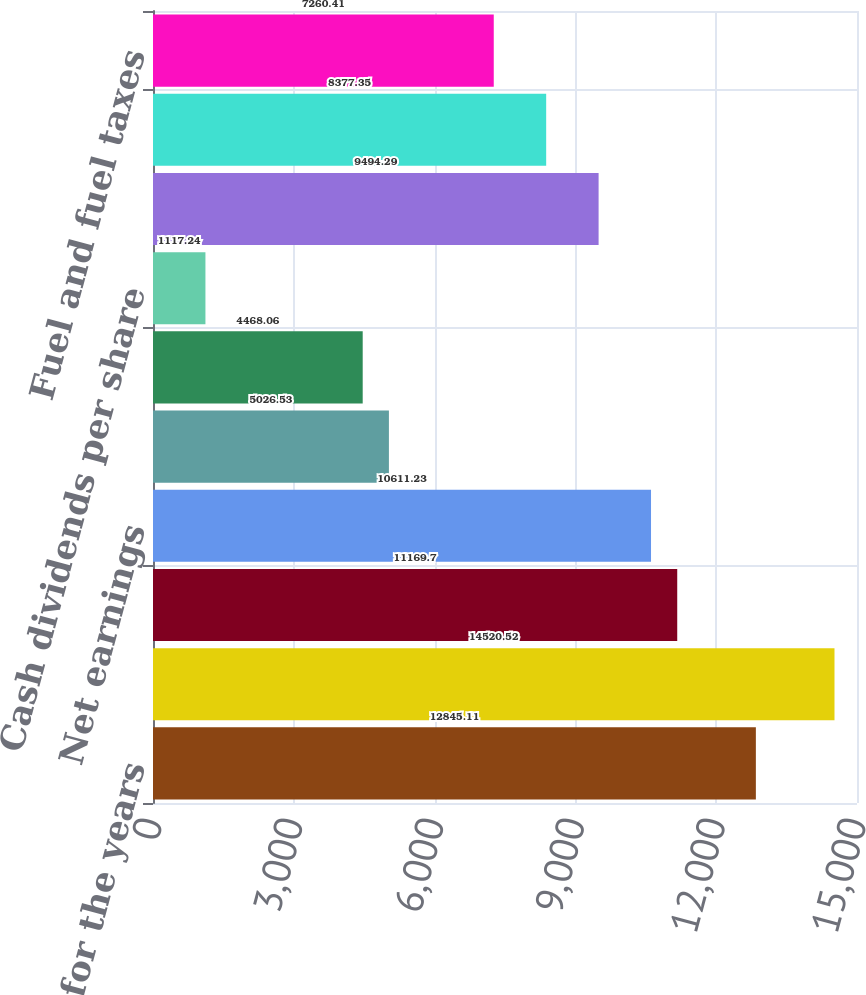Convert chart. <chart><loc_0><loc_0><loc_500><loc_500><bar_chart><fcel>Earnings data for the years<fcel>Operating revenues<fcel>Operating income<fcel>Net earnings<fcel>Basic earnings per share<fcel>Diluted earnings per share<fcel>Cash dividends per share<fcel>Rents and purchased<fcel>Salaries wages and employee<fcel>Fuel and fuel taxes<nl><fcel>12845.1<fcel>14520.5<fcel>11169.7<fcel>10611.2<fcel>5026.53<fcel>4468.06<fcel>1117.24<fcel>9494.29<fcel>8377.35<fcel>7260.41<nl></chart> 